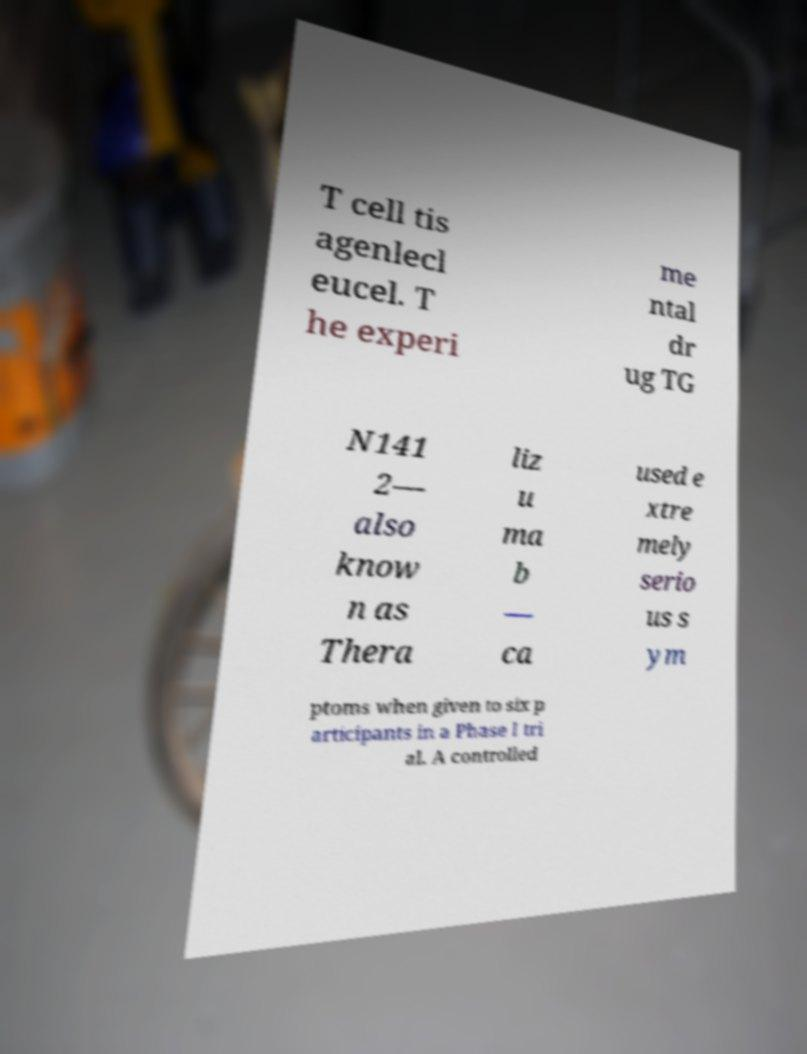For documentation purposes, I need the text within this image transcribed. Could you provide that? T cell tis agenlecl eucel. T he experi me ntal dr ug TG N141 2— also know n as Thera liz u ma b — ca used e xtre mely serio us s ym ptoms when given to six p articipants in a Phase I tri al. A controlled 